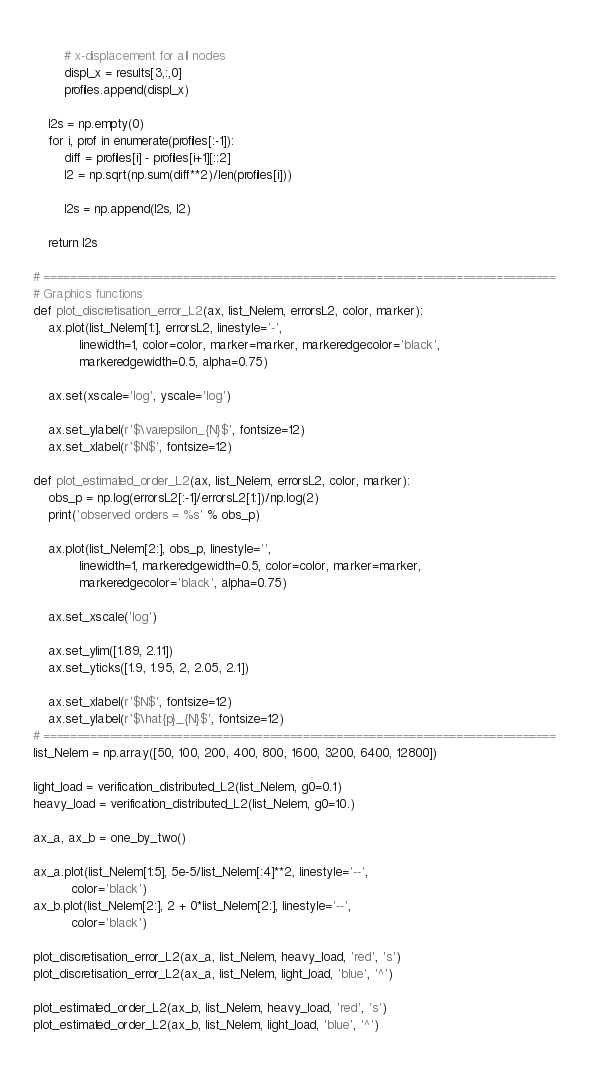Convert code to text. <code><loc_0><loc_0><loc_500><loc_500><_Python_>        
        # x-displacement for all nodes
        displ_x = results[3,:,0]
        profiles.append(displ_x)
        
    l2s = np.empty(0)
    for i, prof in enumerate(profiles[:-1]):
        diff = profiles[i] - profiles[i+1][::2]
        l2 = np.sqrt(np.sum(diff**2)/len(profiles[i]))
        
        l2s = np.append(l2s, l2)
      
    return l2s

# =============================================================================
# Graphics functions
def plot_discretisation_error_L2(ax, list_Nelem, errorsL2, color, marker):
    ax.plot(list_Nelem[1:], errorsL2, linestyle='-',
            linewidth=1, color=color, marker=marker, markeredgecolor='black',
            markeredgewidth=0.5, alpha=0.75)

    ax.set(xscale='log', yscale='log')
    
    ax.set_ylabel(r'$\varepsilon_{N}$', fontsize=12)
    ax.set_xlabel(r'$N$', fontsize=12)
    
def plot_estimated_order_L2(ax, list_Nelem, errorsL2, color, marker):
    obs_p = np.log(errorsL2[:-1]/errorsL2[1:])/np.log(2)
    print('observed orders = %s' % obs_p)
    
    ax.plot(list_Nelem[2:], obs_p, linestyle='',
            linewidth=1, markeredgewidth=0.5, color=color, marker=marker,
            markeredgecolor='black', alpha=0.75)
    
    ax.set_xscale('log')
    
    ax.set_ylim([1.89, 2.11])
    ax.set_yticks([1.9, 1.95, 2, 2.05, 2.1])

    ax.set_xlabel(r'$N$', fontsize=12)
    ax.set_ylabel(r'$\hat{p}_{N}$', fontsize=12)
# =============================================================================
list_Nelem = np.array([50, 100, 200, 400, 800, 1600, 3200, 6400, 12800])

light_load = verification_distributed_L2(list_Nelem, g0=0.1)
heavy_load = verification_distributed_L2(list_Nelem, g0=10.)

ax_a, ax_b = one_by_two()

ax_a.plot(list_Nelem[1:5], 5e-5/list_Nelem[:4]**2, linestyle='--',
          color='black')
ax_b.plot(list_Nelem[2:], 2 + 0*list_Nelem[2:], linestyle='--',
          color='black')

plot_discretisation_error_L2(ax_a, list_Nelem, heavy_load, 'red', 's')
plot_discretisation_error_L2(ax_a, list_Nelem, light_load, 'blue', '^')

plot_estimated_order_L2(ax_b, list_Nelem, heavy_load, 'red', 's')
plot_estimated_order_L2(ax_b, list_Nelem, light_load, 'blue', '^')
</code> 